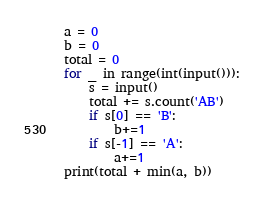<code> <loc_0><loc_0><loc_500><loc_500><_Python_>a = 0
b = 0
total = 0
for _ in range(int(input())):
    s = input()
    total += s.count('AB')
    if s[0] == 'B':
        b+=1
    if s[-1] == 'A':
        a+=1
print(total + min(a, b))


</code> 